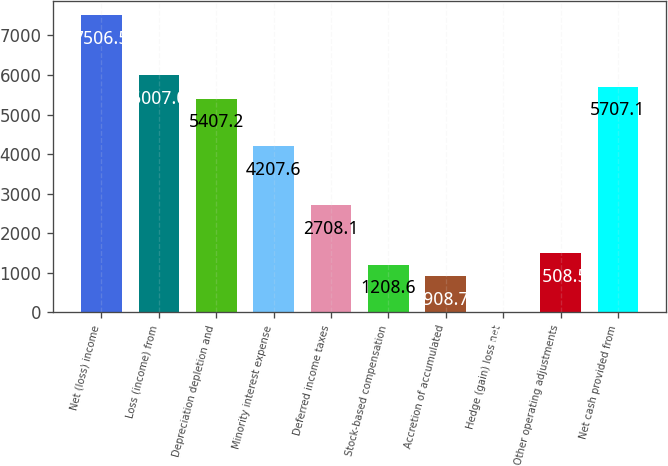Convert chart. <chart><loc_0><loc_0><loc_500><loc_500><bar_chart><fcel>Net (loss) income<fcel>Loss (income) from<fcel>Depreciation depletion and<fcel>Minority interest expense<fcel>Deferred income taxes<fcel>Stock-based compensation<fcel>Accretion of accumulated<fcel>Hedge (gain) loss net<fcel>Other operating adjustments<fcel>Net cash provided from<nl><fcel>7506.5<fcel>6007<fcel>5407.2<fcel>4207.6<fcel>2708.1<fcel>1208.6<fcel>908.7<fcel>9<fcel>1508.5<fcel>5707.1<nl></chart> 